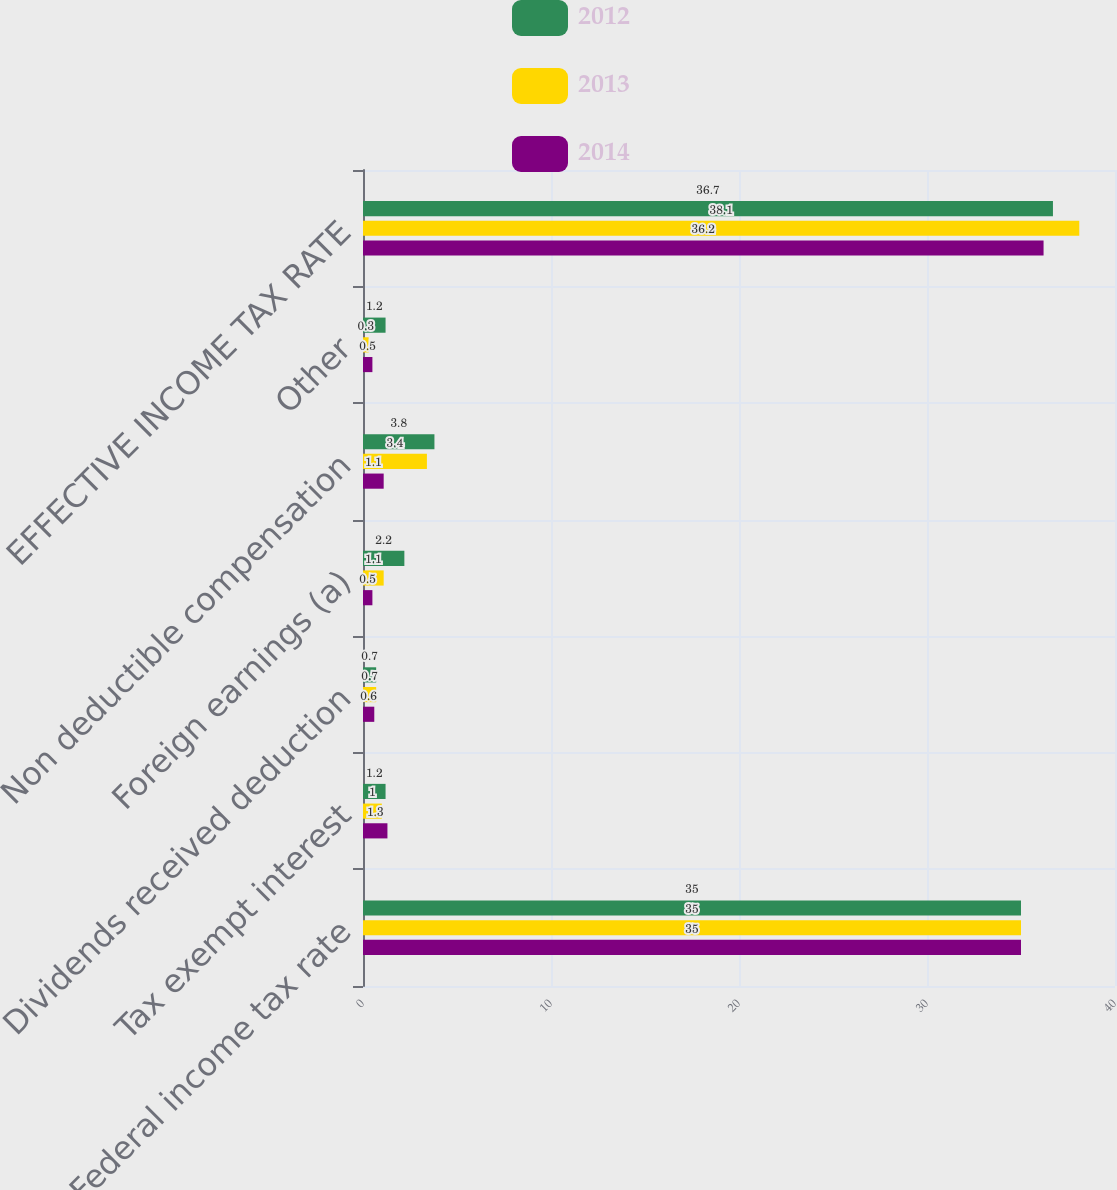Convert chart to OTSL. <chart><loc_0><loc_0><loc_500><loc_500><stacked_bar_chart><ecel><fcel>Federal income tax rate<fcel>Tax exempt interest<fcel>Dividends received deduction<fcel>Foreign earnings (a)<fcel>Non deductible compensation<fcel>Other<fcel>EFFECTIVE INCOME TAX RATE<nl><fcel>2012<fcel>35<fcel>1.2<fcel>0.7<fcel>2.2<fcel>3.8<fcel>1.2<fcel>36.7<nl><fcel>2013<fcel>35<fcel>1<fcel>0.7<fcel>1.1<fcel>3.4<fcel>0.3<fcel>38.1<nl><fcel>2014<fcel>35<fcel>1.3<fcel>0.6<fcel>0.5<fcel>1.1<fcel>0.5<fcel>36.2<nl></chart> 